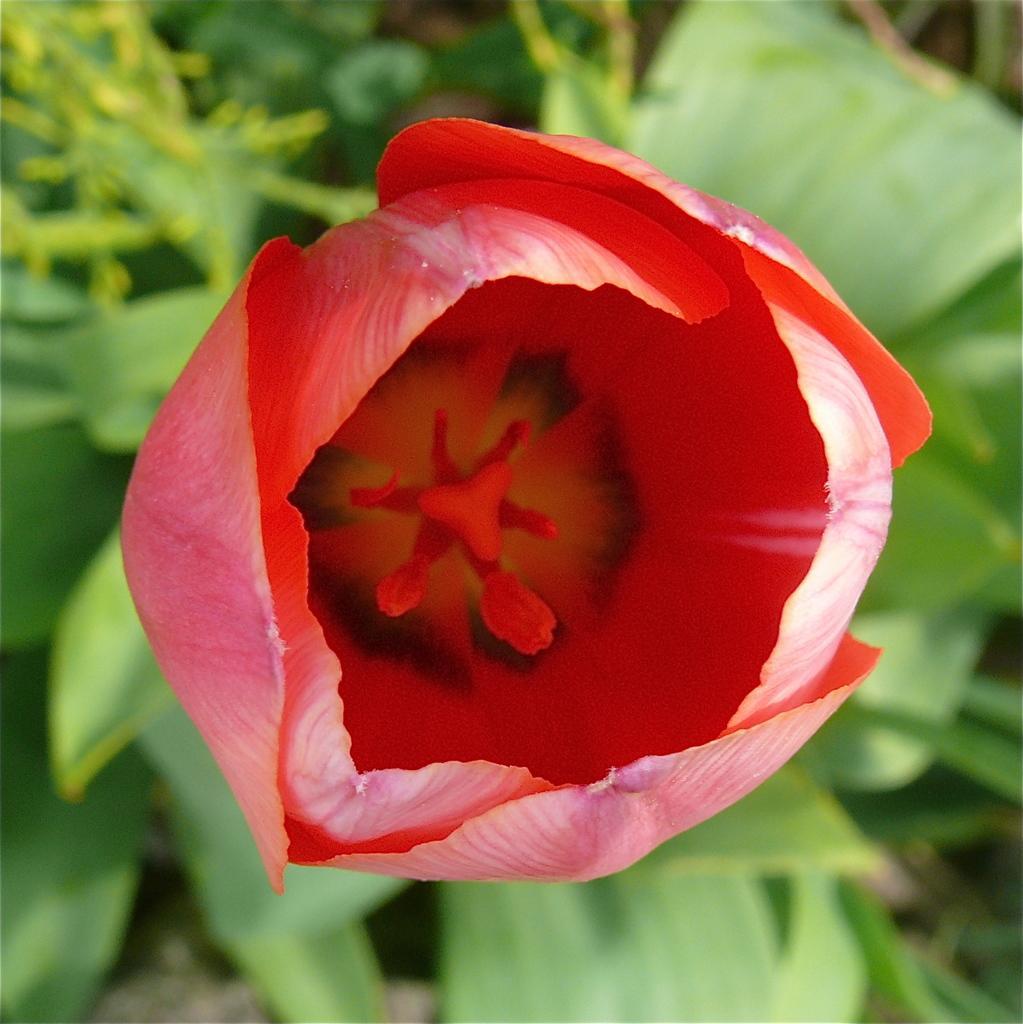Could you give a brief overview of what you see in this image? In this image I can see red color flower. Back I can see green color leaves. 